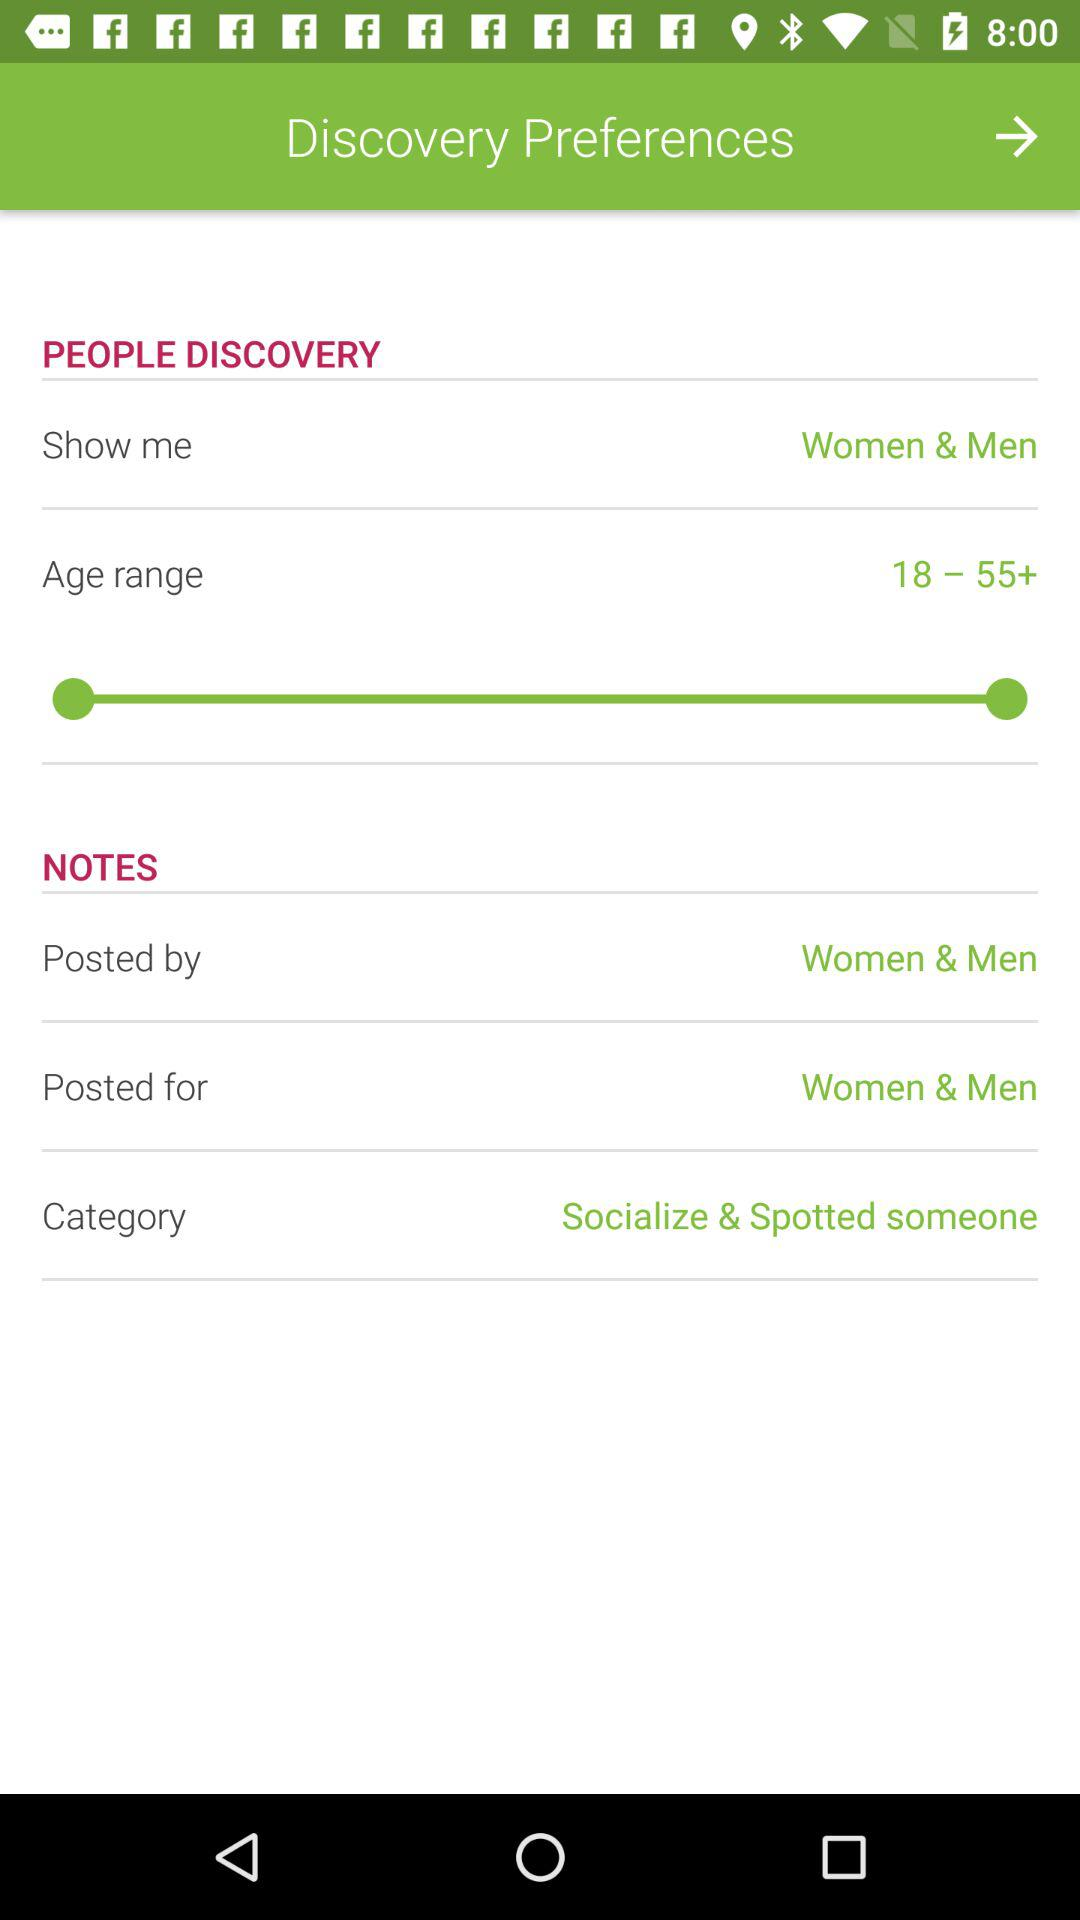By whom was it posted? It was posted by women and men. 